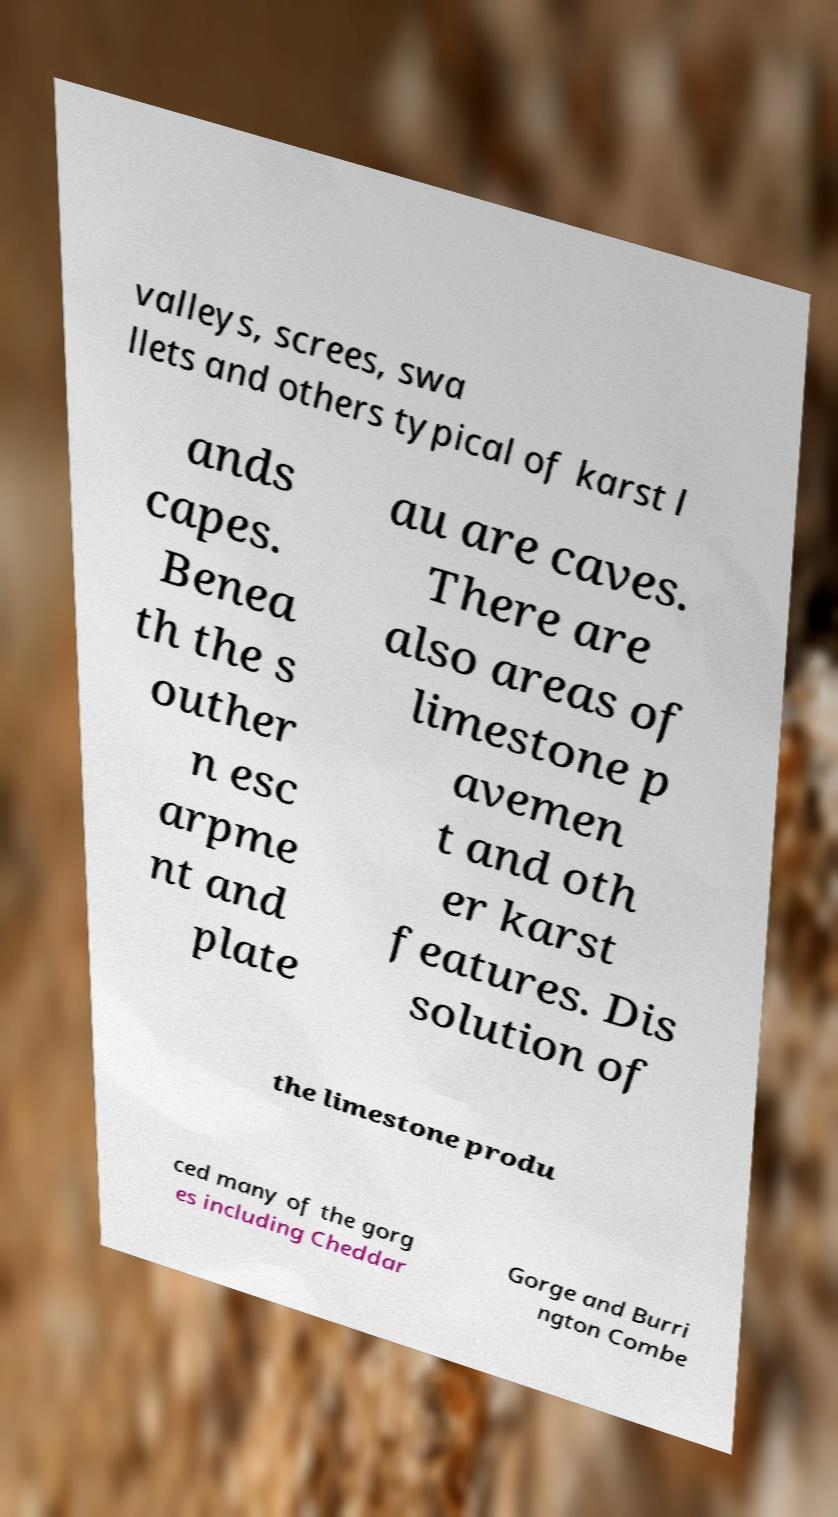What messages or text are displayed in this image? I need them in a readable, typed format. valleys, screes, swa llets and others typical of karst l ands capes. Benea th the s outher n esc arpme nt and plate au are caves. There are also areas of limestone p avemen t and oth er karst features. Dis solution of the limestone produ ced many of the gorg es including Cheddar Gorge and Burri ngton Combe 